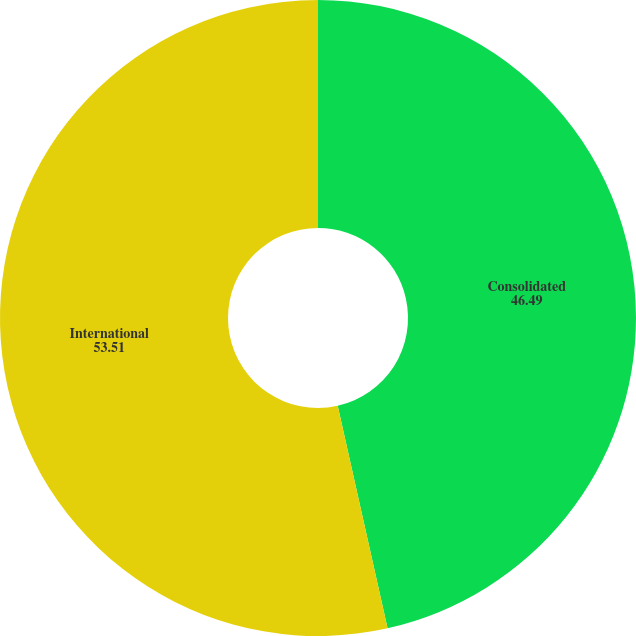Convert chart. <chart><loc_0><loc_0><loc_500><loc_500><pie_chart><fcel>Consolidated<fcel>International<nl><fcel>46.49%<fcel>53.51%<nl></chart> 